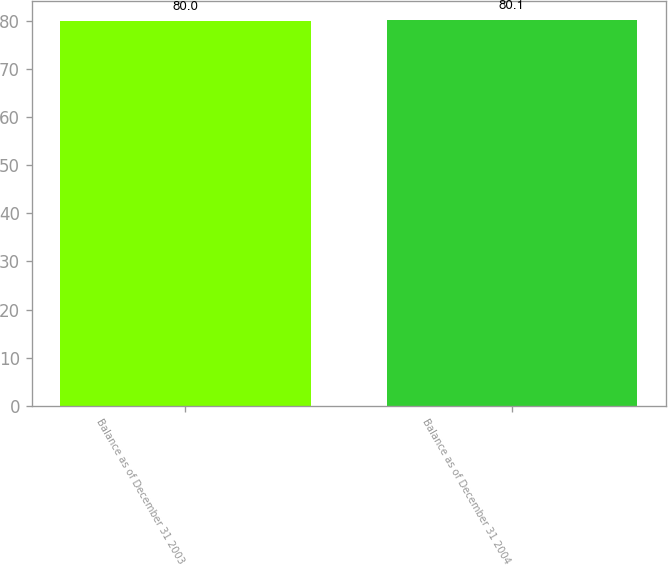Convert chart to OTSL. <chart><loc_0><loc_0><loc_500><loc_500><bar_chart><fcel>Balance as of December 31 2003<fcel>Balance as of December 31 2004<nl><fcel>80<fcel>80.1<nl></chart> 